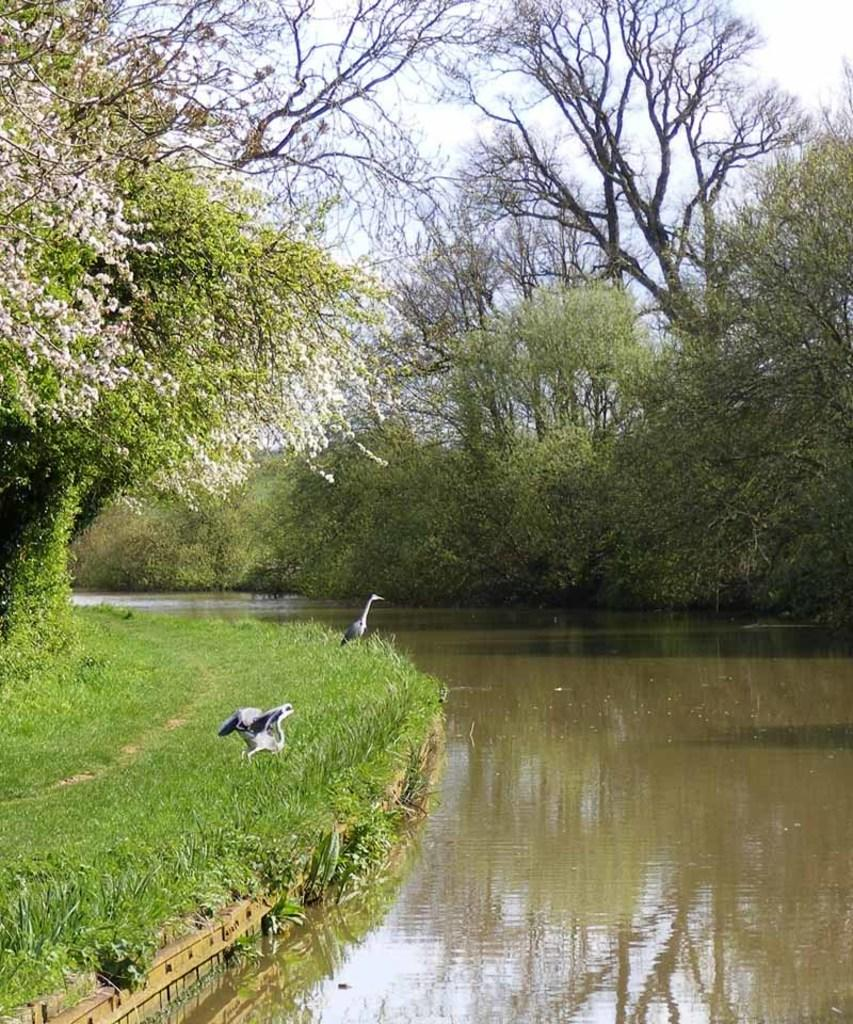What is the primary element visible in the image? There is water in the image. What type of surface can be seen beneath the water? There is ground visible in the image, and grass is present on the ground. What type of living organisms can be seen in the image? Birds are visible in the image. What type of vegetation is present on both sides of the water? There are trees on both sides of the water in the image. What other type of plant life can be seen in the image? There are flowers in the image. What can be seen in the background of the image? The sky is visible in the background of the image. How does the guide help the dust in the image? There is no guide or dust present in the image. Can you describe the romantic interaction between the birds in the image? There is no romantic interaction or kissing between the birds in the image; they are simply flying or perched. 